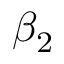Convert formula to latex. <formula><loc_0><loc_0><loc_500><loc_500>\beta _ { 2 }</formula> 